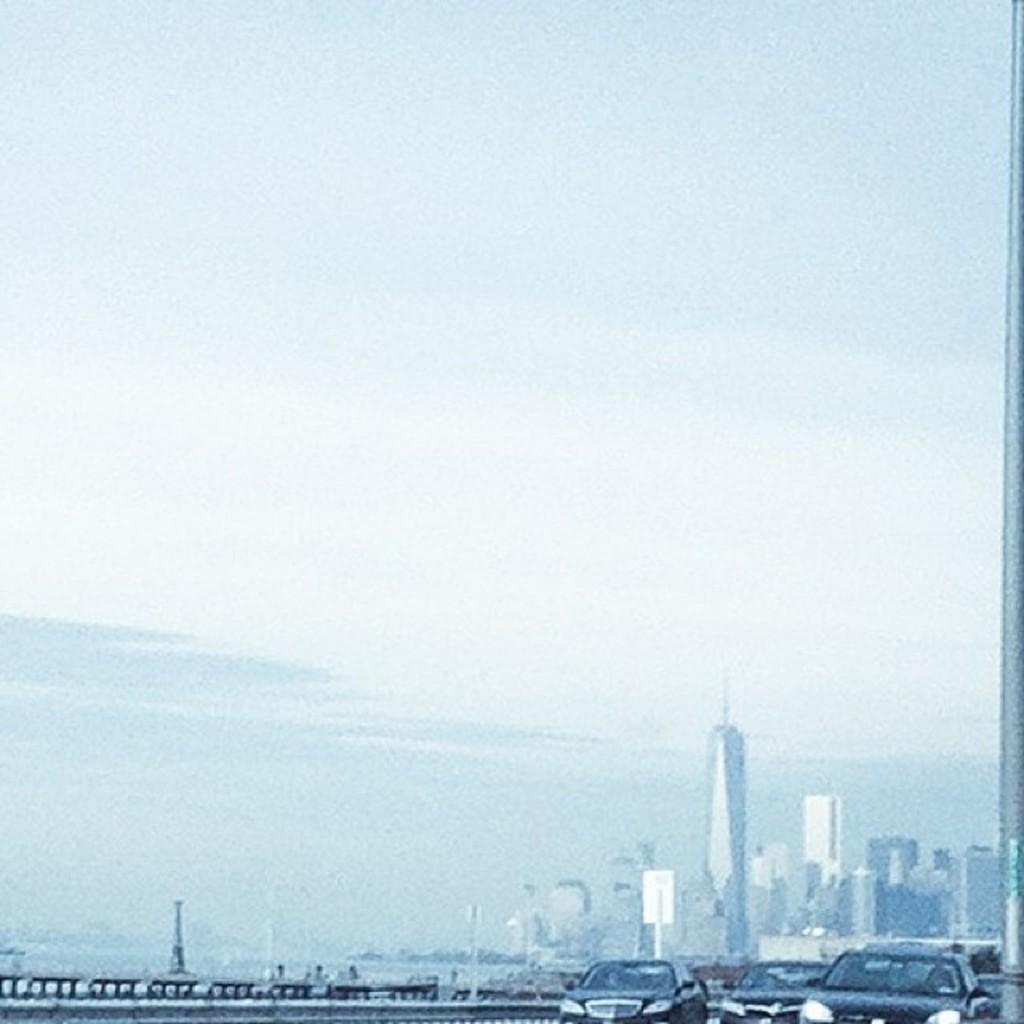Please provide a concise description of this image. In the picture we can see the cars, buildings and the sky with clouds. 